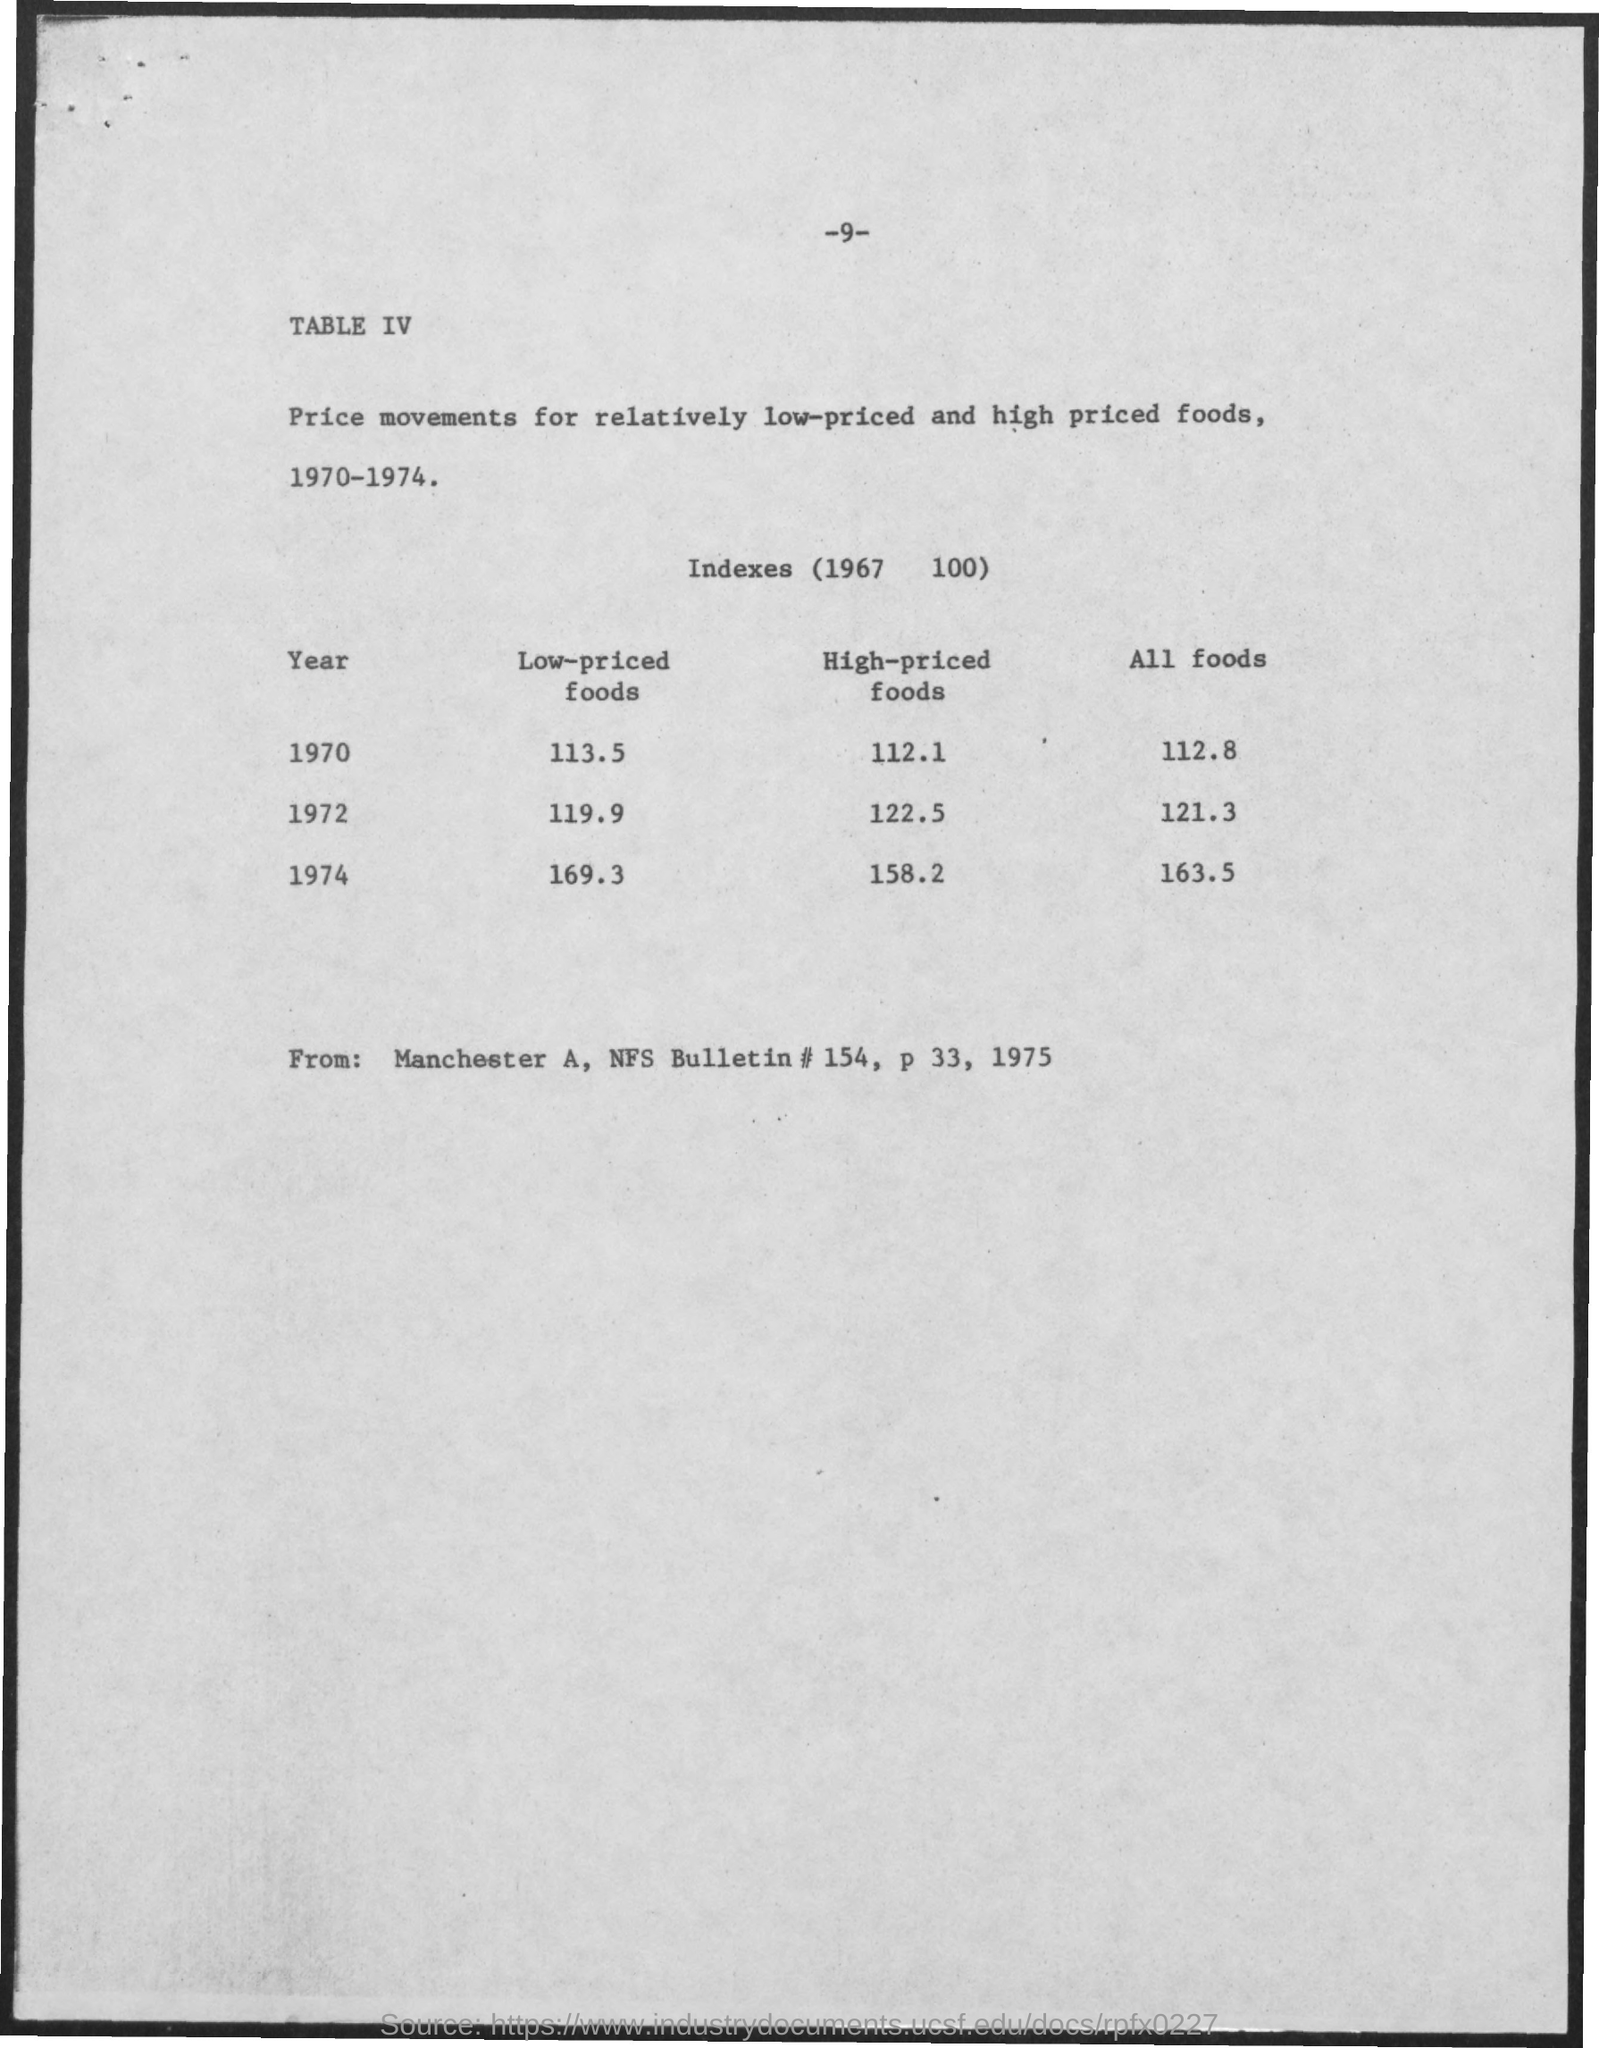What is the "Low-priced foods" Index for 1970?
Keep it short and to the point. 113 5. What is the "Low-priced foods" Index for 1972?
Keep it short and to the point. 119 9. What is the "Low-priced foods" Index for 1974?
Provide a succinct answer. 169 3. What is the "High-priced foods" Index for 1970?
Offer a terse response. 112 1. What is the "High-priced foods" Index for 1972?
Offer a terse response. 122 5. What is the "High-priced foods" Index for 1974?
Give a very brief answer. 158 2. What is the "All foods" Index for 1970?
Offer a very short reply. 112 8. What is the "All foods" Index for 1972?
Provide a succinct answer. 121 3. What is the "All foods" Index for 1974?
Give a very brief answer. 163 5. 